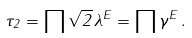<formula> <loc_0><loc_0><loc_500><loc_500>\tau _ { 2 } = \prod \sqrt { 2 } \, \lambda ^ { E } = \prod \gamma ^ { E } \, .</formula> 